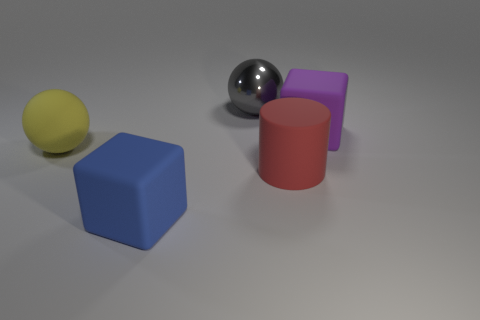Are the large block to the right of the red cylinder and the big gray sphere made of the same material?
Provide a succinct answer. No. Is there anything else that is the same shape as the large red rubber object?
Your answer should be compact. No. Is the blue matte object the same shape as the purple matte thing?
Your answer should be very brief. Yes. Are there an equal number of blue things that are behind the gray thing and big purple matte blocks that are to the right of the blue rubber block?
Your response must be concise. No. What number of other things are there of the same material as the red cylinder
Your answer should be very brief. 3. How many small objects are brown metal blocks or red things?
Ensure brevity in your answer.  0. Are there the same number of large red matte things that are left of the big gray ball and purple objects?
Ensure brevity in your answer.  No. Is there a sphere behind the rubber cube in front of the red object?
Provide a short and direct response. Yes. What color is the metallic ball?
Provide a succinct answer. Gray. What is the size of the rubber thing that is both to the right of the metallic ball and to the left of the purple object?
Offer a very short reply. Large. 